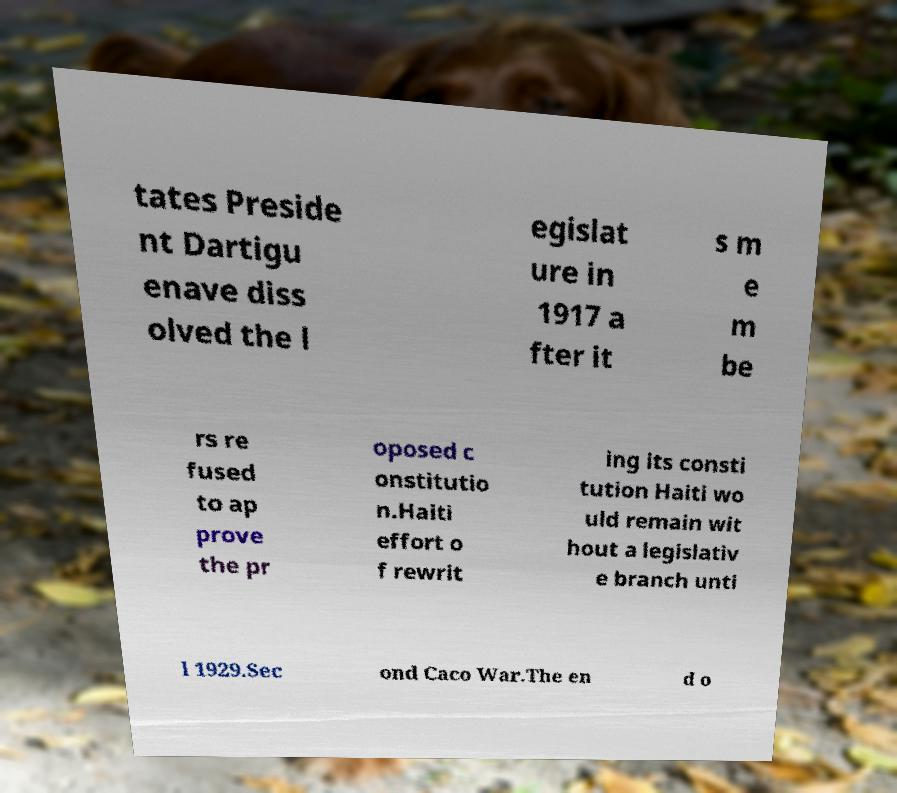Can you read and provide the text displayed in the image?This photo seems to have some interesting text. Can you extract and type it out for me? tates Preside nt Dartigu enave diss olved the l egislat ure in 1917 a fter it s m e m be rs re fused to ap prove the pr oposed c onstitutio n.Haiti effort o f rewrit ing its consti tution Haiti wo uld remain wit hout a legislativ e branch unti l 1929.Sec ond Caco War.The en d o 